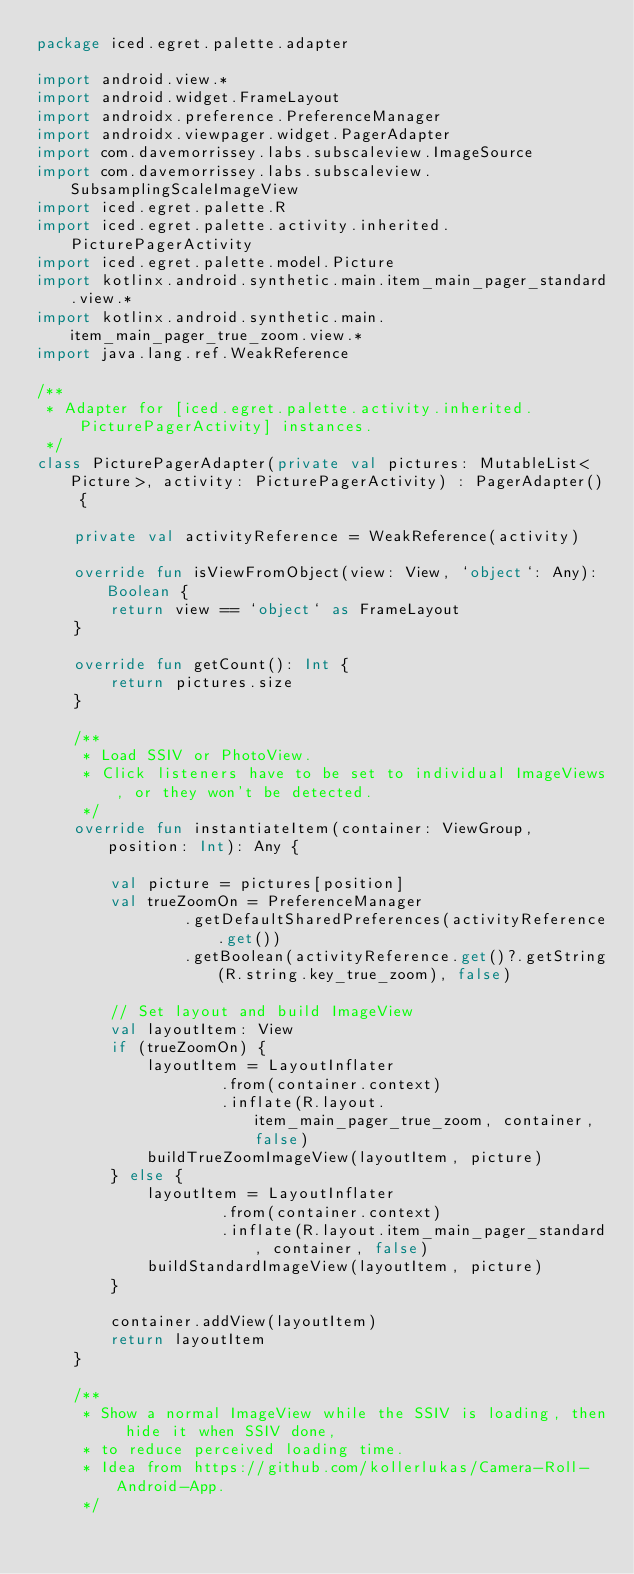Convert code to text. <code><loc_0><loc_0><loc_500><loc_500><_Kotlin_>package iced.egret.palette.adapter

import android.view.*
import android.widget.FrameLayout
import androidx.preference.PreferenceManager
import androidx.viewpager.widget.PagerAdapter
import com.davemorrissey.labs.subscaleview.ImageSource
import com.davemorrissey.labs.subscaleview.SubsamplingScaleImageView
import iced.egret.palette.R
import iced.egret.palette.activity.inherited.PicturePagerActivity
import iced.egret.palette.model.Picture
import kotlinx.android.synthetic.main.item_main_pager_standard.view.*
import kotlinx.android.synthetic.main.item_main_pager_true_zoom.view.*
import java.lang.ref.WeakReference

/**
 * Adapter for [iced.egret.palette.activity.inherited.PicturePagerActivity] instances.
 */
class PicturePagerAdapter(private val pictures: MutableList<Picture>, activity: PicturePagerActivity) : PagerAdapter() {

    private val activityReference = WeakReference(activity)

    override fun isViewFromObject(view: View, `object`: Any): Boolean {
        return view == `object` as FrameLayout
    }

    override fun getCount(): Int {
        return pictures.size
    }

    /**
     * Load SSIV or PhotoView.
     * Click listeners have to be set to individual ImageViews, or they won't be detected.
     */
    override fun instantiateItem(container: ViewGroup, position: Int): Any {

        val picture = pictures[position]
        val trueZoomOn = PreferenceManager
                .getDefaultSharedPreferences(activityReference.get())
                .getBoolean(activityReference.get()?.getString(R.string.key_true_zoom), false)

        // Set layout and build ImageView
        val layoutItem: View
        if (trueZoomOn) {
            layoutItem = LayoutInflater
                    .from(container.context)
                    .inflate(R.layout.item_main_pager_true_zoom, container, false)
            buildTrueZoomImageView(layoutItem, picture)
        } else {
            layoutItem = LayoutInflater
                    .from(container.context)
                    .inflate(R.layout.item_main_pager_standard, container, false)
            buildStandardImageView(layoutItem, picture)
        }

        container.addView(layoutItem)
        return layoutItem
    }

    /**
     * Show a normal ImageView while the SSIV is loading, then hide it when SSIV done,
     * to reduce perceived loading time.
     * Idea from https://github.com/kollerlukas/Camera-Roll-Android-App.
     */</code> 